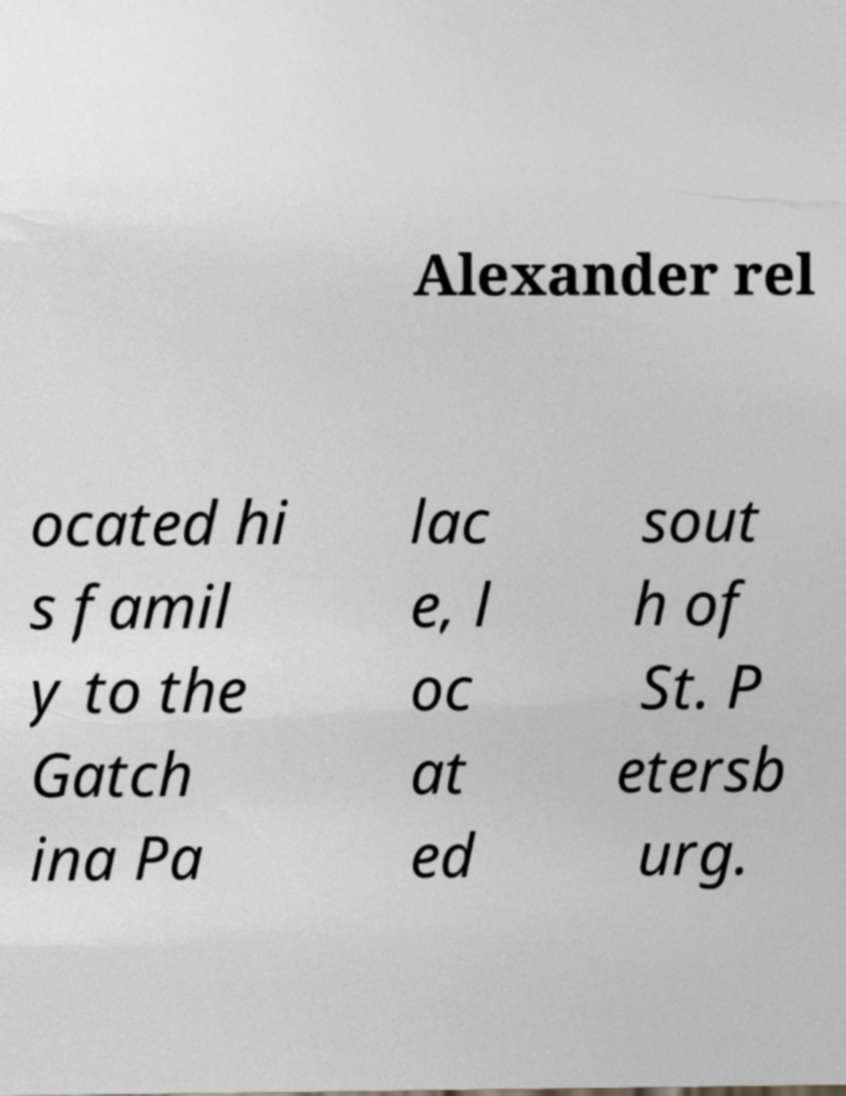I need the written content from this picture converted into text. Can you do that? Alexander rel ocated hi s famil y to the Gatch ina Pa lac e, l oc at ed sout h of St. P etersb urg. 